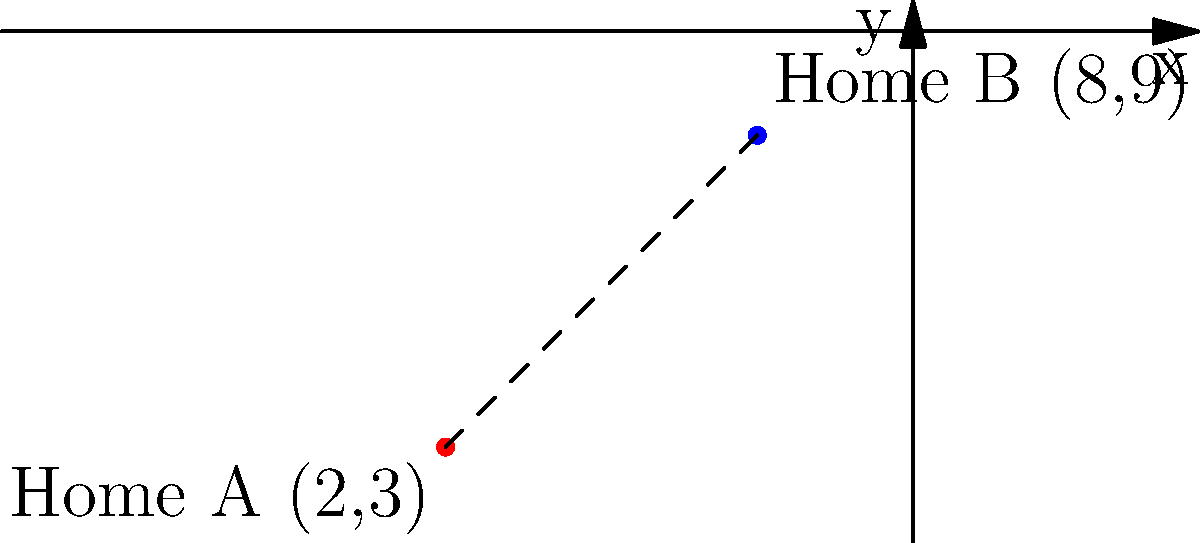A couple is considering two potential homes for downsizing after their children have moved out. On a city map, Home A is located at coordinates (2,3) and Home B is at (8,9). Using the distance formula, calculate the straight-line distance between these two homes. Round your answer to two decimal places. To find the distance between two points on a coordinate plane, we use the distance formula:

$$d = \sqrt{(x_2 - x_1)^2 + (y_2 - y_1)^2}$$

Where $(x_1, y_1)$ are the coordinates of the first point and $(x_2, y_2)$ are the coordinates of the second point.

Given:
- Home A: $(x_1, y_1) = (2, 3)$
- Home B: $(x_2, y_2) = (8, 9)$

Let's substitute these values into the formula:

$$d = \sqrt{(8 - 2)^2 + (9 - 3)^2}$$

Now, let's solve step by step:

1) Simplify the expressions inside the parentheses:
   $$d = \sqrt{6^2 + 6^2}$$

2) Calculate the squares:
   $$d = \sqrt{36 + 36}$$

3) Add the values under the square root:
   $$d = \sqrt{72}$$

4) Simplify the square root:
   $$d = 6\sqrt{2}$$

5) Use a calculator to approximate and round to two decimal places:
   $$d \approx 8.49$$

Therefore, the straight-line distance between Home A and Home B is approximately 8.49 units on the city map.
Answer: 8.49 units 